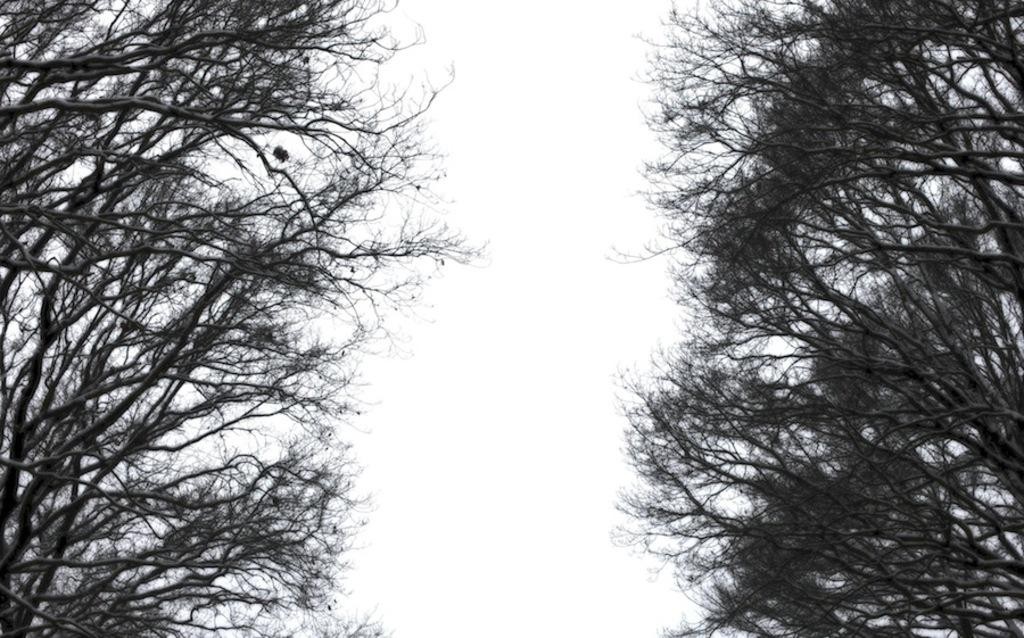What type of vegetation can be seen on both sides of the image? There is a tree on both sides of the image. What part of the natural environment is visible in the middle of the image? There is a part of the sky visible in the middle of the image. What type of loaf can be seen in the picture? There is no loaf present in the image; it features trees on both sides and a part of the sky in the middle. 